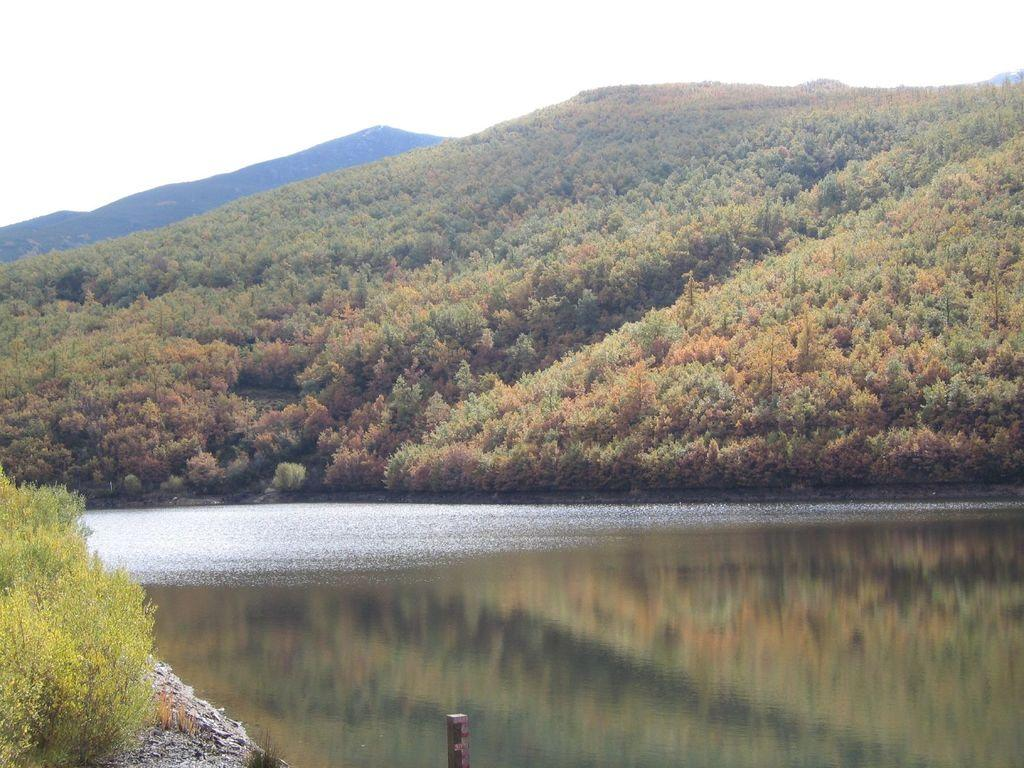What is the main feature of the image? There is a large water body in the image. What else can be seen in the image besides the water body? There are plants and a group of trees on the hills in the image. How would you describe the sky in the image? The sky is visible in the image and appears cloudy. Can you identify any man-made structures in the image? There is a pole at the bottom of the image. What type of egg is being used in the meal depicted in the image? There is no meal or egg present in the image; it features a large water body, plants, trees, a cloudy sky, and a pole. 